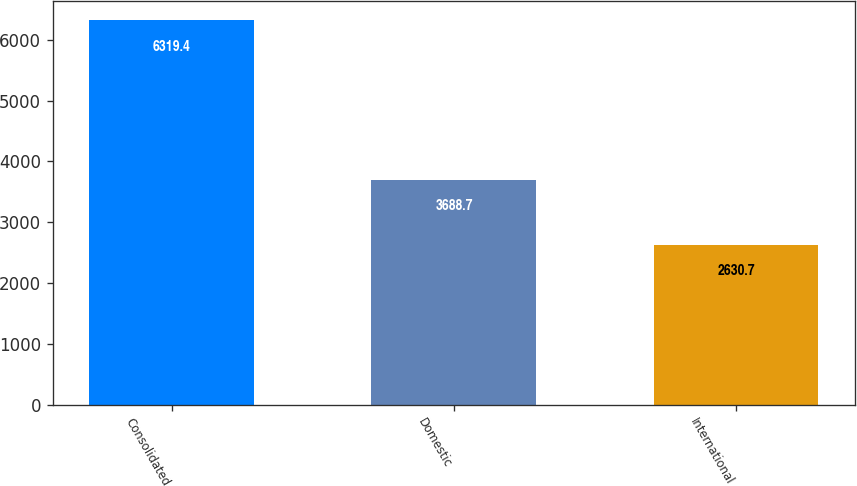<chart> <loc_0><loc_0><loc_500><loc_500><bar_chart><fcel>Consolidated<fcel>Domestic<fcel>International<nl><fcel>6319.4<fcel>3688.7<fcel>2630.7<nl></chart> 